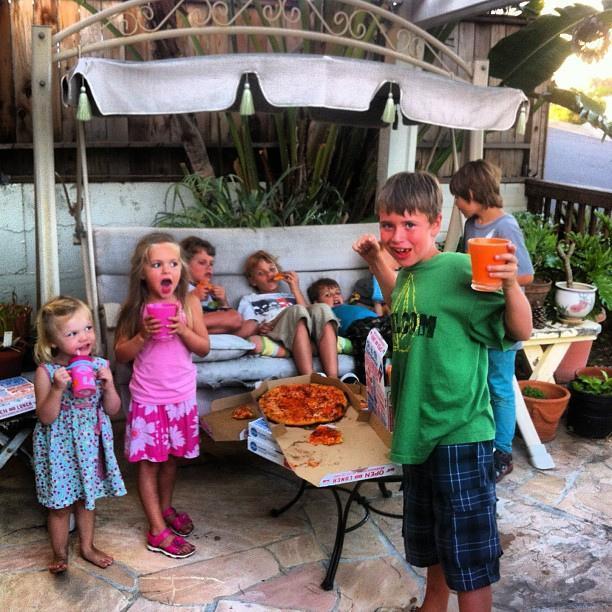How many girls are in the picture?
Give a very brief answer. 2. How many potted plants can you see?
Give a very brief answer. 2. How many people can be seen?
Give a very brief answer. 7. 